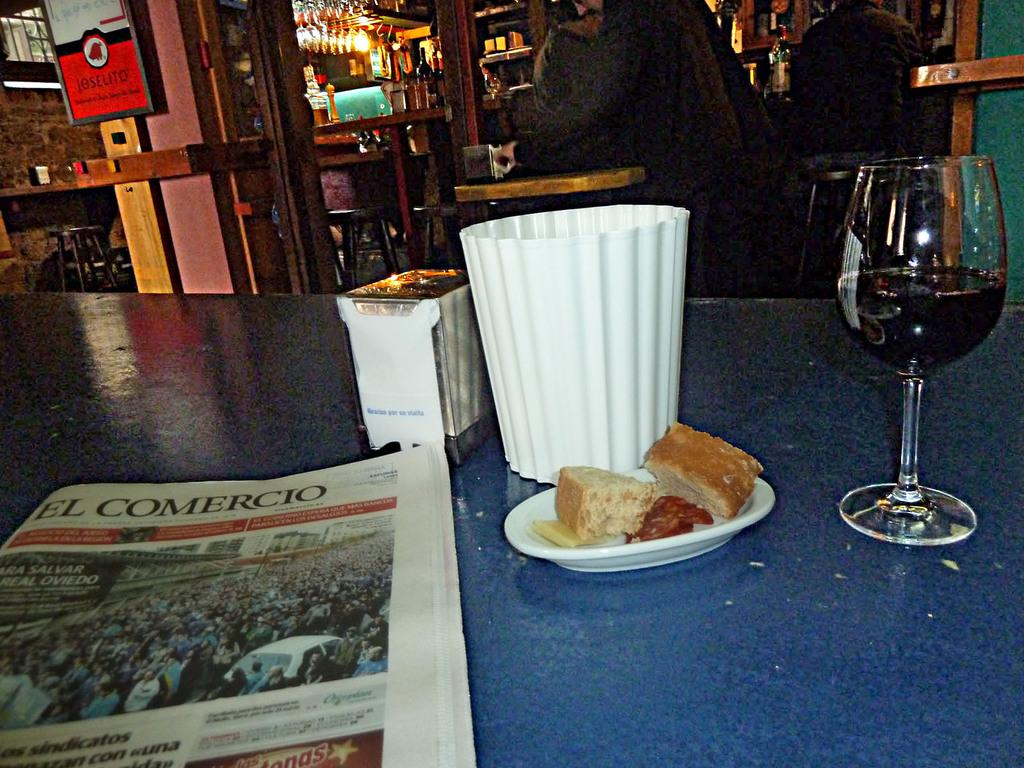<image>
Offer a succinct explanation of the picture presented. El Comercio newspaper is on a restaurant table with food and wine. 